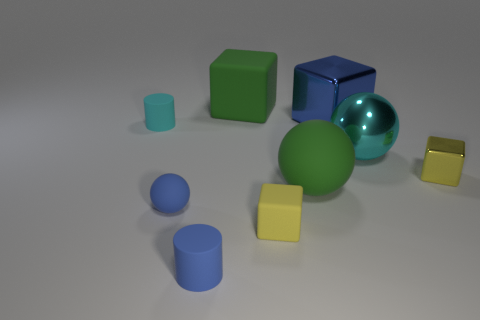How big is the blue block?
Give a very brief answer. Large. How many things are either large brown matte spheres or cyan objects?
Provide a succinct answer. 2. There is a small block that is the same material as the big cyan object; what color is it?
Keep it short and to the point. Yellow. There is a green thing behind the tiny yellow shiny object; is its shape the same as the tiny cyan matte thing?
Keep it short and to the point. No. What number of things are either blue objects behind the blue rubber cylinder or tiny rubber things that are behind the yellow shiny object?
Give a very brief answer. 3. What is the color of the other big rubber object that is the same shape as the yellow rubber object?
Your response must be concise. Green. Is there anything else that is the same shape as the cyan metal object?
Make the answer very short. Yes. There is a cyan metal thing; is its shape the same as the green rubber object that is in front of the big green cube?
Provide a succinct answer. Yes. What is the material of the small cyan cylinder?
Keep it short and to the point. Rubber. What size is the blue object that is the same shape as the big cyan metallic thing?
Give a very brief answer. Small. 